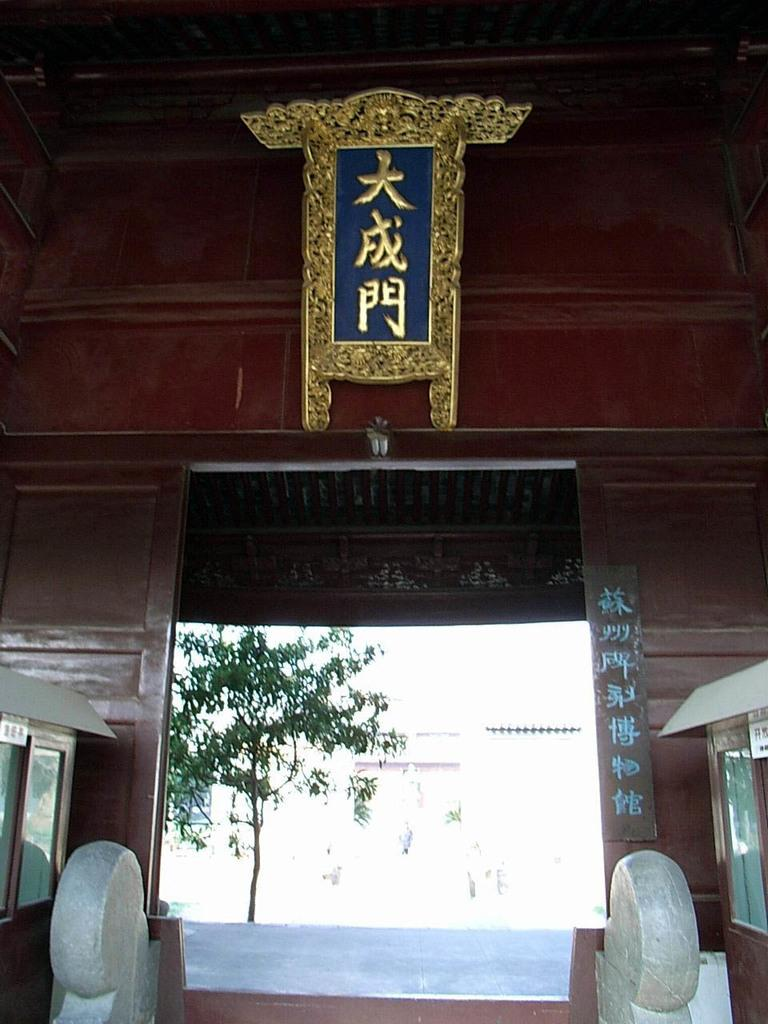What type of view is shown in the image? The image shows an inner view of a building. What natural element can be seen in the image? There is a tree visible in the image. What else can be seen in the image besides the tree? There is another building visible in the image. What type of dolls can be seen sleeping in the image? There are no dolls present in the image, and therefore no dolls can be seen sleeping. 